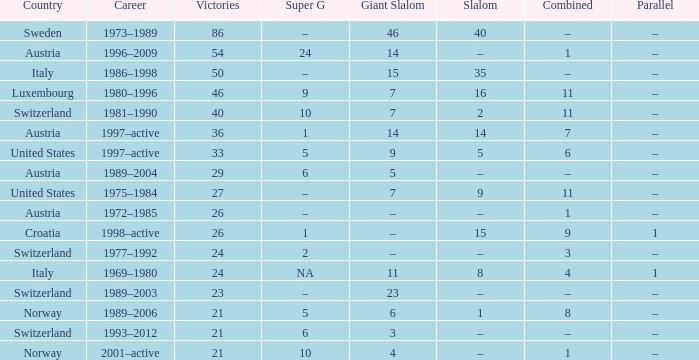In which occupation can you find a parallel of –, a combined of –, and a giant slalom score of 5? 1989–2004. Would you be able to parse every entry in this table? {'header': ['Country', 'Career', 'Victories', 'Super G', 'Giant Slalom', 'Slalom', 'Combined', 'Parallel'], 'rows': [['Sweden', '1973–1989', '86', '–', '46', '40', '–', '–'], ['Austria', '1996–2009', '54', '24', '14', '–', '1', '–'], ['Italy', '1986–1998', '50', '–', '15', '35', '–', '–'], ['Luxembourg', '1980–1996', '46', '9', '7', '16', '11', '–'], ['Switzerland', '1981–1990', '40', '10', '7', '2', '11', '–'], ['Austria', '1997–active', '36', '1', '14', '14', '7', '–'], ['United States', '1997–active', '33', '5', '9', '5', '6', '–'], ['Austria', '1989–2004', '29', '6', '5', '–', '–', '–'], ['United States', '1975–1984', '27', '–', '7', '9', '11', '–'], ['Austria', '1972–1985', '26', '–', '–', '–', '1', '–'], ['Croatia', '1998–active', '26', '1', '–', '15', '9', '1'], ['Switzerland', '1977–1992', '24', '2', '–', '–', '3', '–'], ['Italy', '1969–1980', '24', 'NA', '11', '8', '4', '1'], ['Switzerland', '1989–2003', '23', '–', '23', '–', '–', '–'], ['Norway', '1989–2006', '21', '5', '6', '1', '8', '–'], ['Switzerland', '1993–2012', '21', '6', '3', '–', '–', '–'], ['Norway', '2001–active', '21', '10', '4', '–', '1', '–']]} 